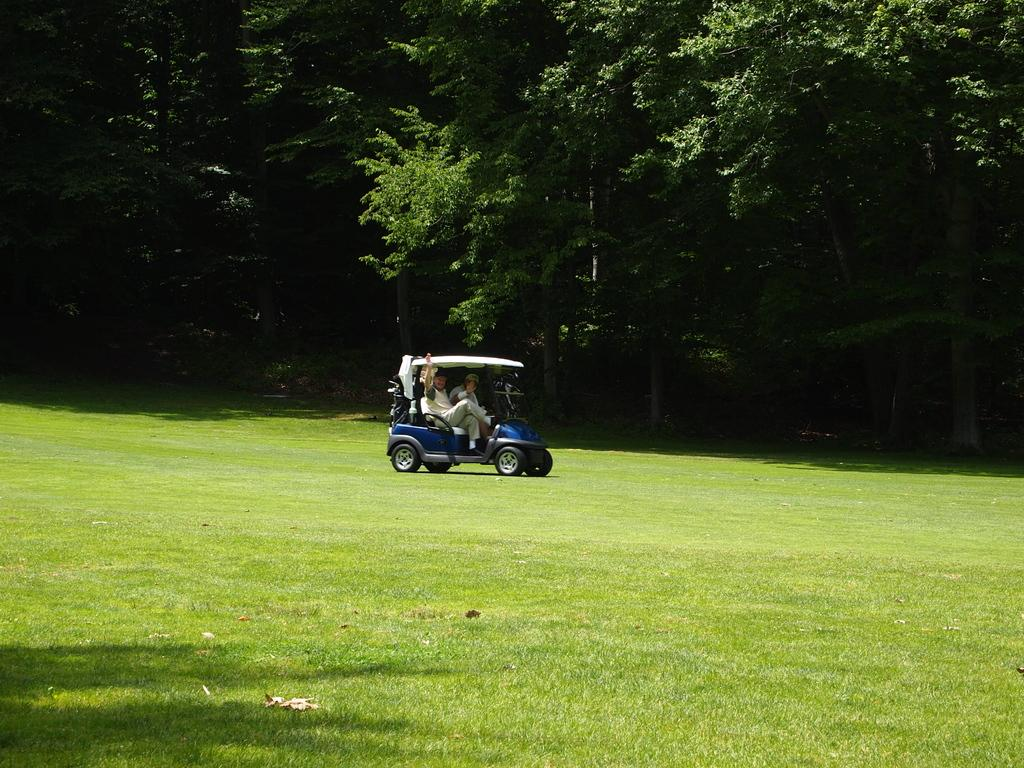Who or what is present in the image? There are people in the image. What are the people doing in the image? The people are riding in a golf cart. Where is the golf cart located? The golf cart is on green grass. What can be seen in the surroundings of the golf cart? Trees are present in the surroundings. What type of currency is being exchanged in the image? There is no indication of currency exchange in the image; it features people riding in a golf cart on green grass with trees in the surroundings. 